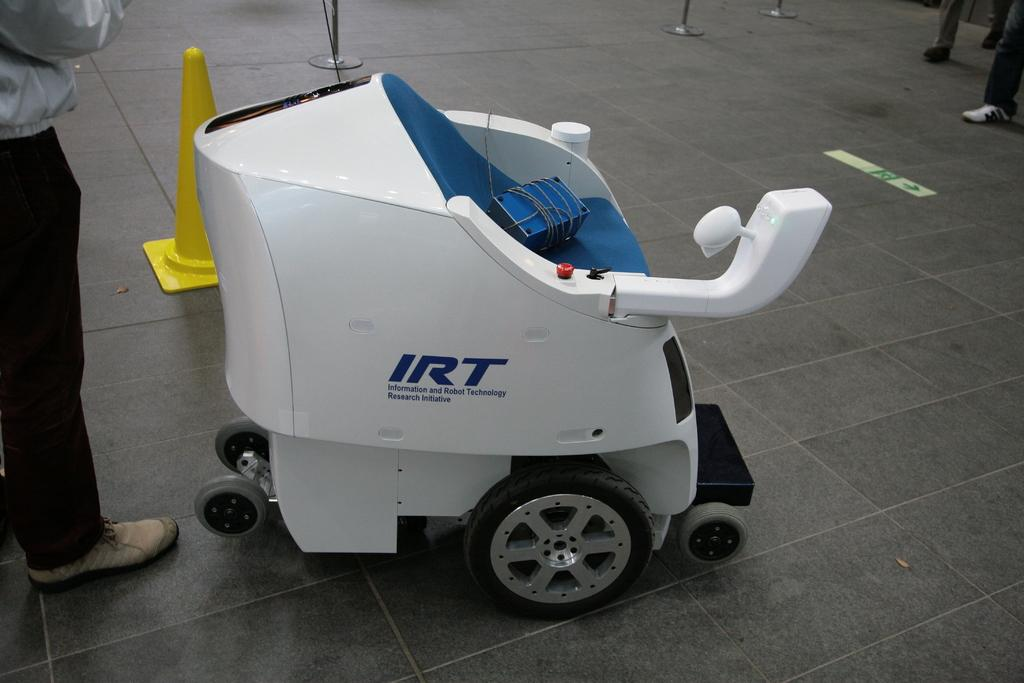<image>
Write a terse but informative summary of the picture. "Informative and Robot Technology Research Initiative" is printed onto the side of this cart. 